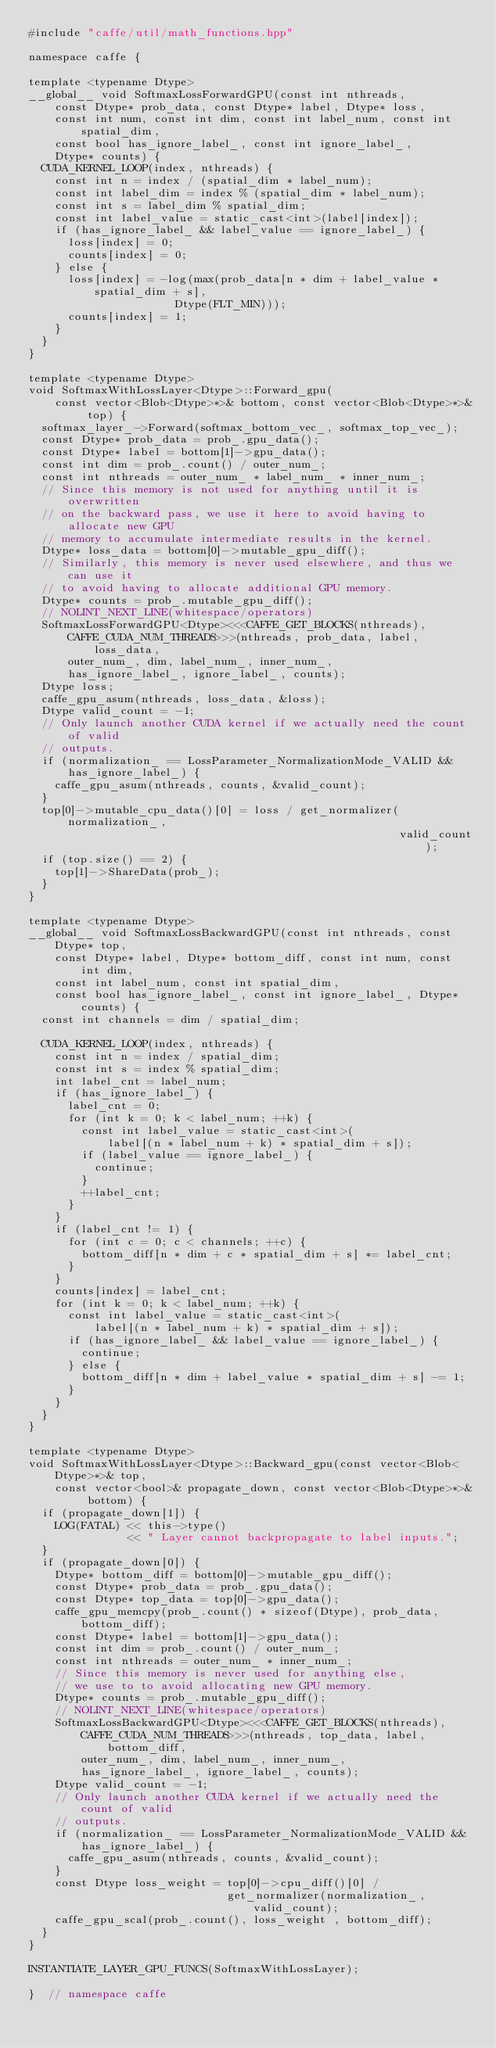<code> <loc_0><loc_0><loc_500><loc_500><_Cuda_>#include "caffe/util/math_functions.hpp"

namespace caffe {

template <typename Dtype>
__global__ void SoftmaxLossForwardGPU(const int nthreads,
    const Dtype* prob_data, const Dtype* label, Dtype* loss,
    const int num, const int dim, const int label_num, const int spatial_dim,
    const bool has_ignore_label_, const int ignore_label_,
    Dtype* counts) {
  CUDA_KERNEL_LOOP(index, nthreads) {
    const int n = index / (spatial_dim * label_num);
    const int label_dim = index % (spatial_dim * label_num);
    const int s = label_dim % spatial_dim;
    const int label_value = static_cast<int>(label[index]);
    if (has_ignore_label_ && label_value == ignore_label_) {
      loss[index] = 0;
      counts[index] = 0;
    } else {
      loss[index] = -log(max(prob_data[n * dim + label_value * spatial_dim + s],
                      Dtype(FLT_MIN)));
      counts[index] = 1;
    }
  }
}

template <typename Dtype>
void SoftmaxWithLossLayer<Dtype>::Forward_gpu(
    const vector<Blob<Dtype>*>& bottom, const vector<Blob<Dtype>*>& top) {
  softmax_layer_->Forward(softmax_bottom_vec_, softmax_top_vec_);
  const Dtype* prob_data = prob_.gpu_data();
  const Dtype* label = bottom[1]->gpu_data();
  const int dim = prob_.count() / outer_num_;
  const int nthreads = outer_num_ * label_num_ * inner_num_;
  // Since this memory is not used for anything until it is overwritten
  // on the backward pass, we use it here to avoid having to allocate new GPU
  // memory to accumulate intermediate results in the kernel.
  Dtype* loss_data = bottom[0]->mutable_gpu_diff();
  // Similarly, this memory is never used elsewhere, and thus we can use it
  // to avoid having to allocate additional GPU memory.
  Dtype* counts = prob_.mutable_gpu_diff();
  // NOLINT_NEXT_LINE(whitespace/operators)
  SoftmaxLossForwardGPU<Dtype><<<CAFFE_GET_BLOCKS(nthreads),
      CAFFE_CUDA_NUM_THREADS>>>(nthreads, prob_data, label, loss_data,
      outer_num_, dim, label_num_, inner_num_,
      has_ignore_label_, ignore_label_, counts);
  Dtype loss;
  caffe_gpu_asum(nthreads, loss_data, &loss);
  Dtype valid_count = -1;
  // Only launch another CUDA kernel if we actually need the count of valid
  // outputs.
  if (normalization_ == LossParameter_NormalizationMode_VALID &&
      has_ignore_label_) {
    caffe_gpu_asum(nthreads, counts, &valid_count);
  }
  top[0]->mutable_cpu_data()[0] = loss / get_normalizer(normalization_,
                                                        valid_count);
  if (top.size() == 2) {
    top[1]->ShareData(prob_);
  }
}

template <typename Dtype>
__global__ void SoftmaxLossBackwardGPU(const int nthreads, const Dtype* top,
    const Dtype* label, Dtype* bottom_diff, const int num, const int dim,
    const int label_num, const int spatial_dim,
    const bool has_ignore_label_, const int ignore_label_, Dtype* counts) {
  const int channels = dim / spatial_dim;

  CUDA_KERNEL_LOOP(index, nthreads) {
    const int n = index / spatial_dim;
    const int s = index % spatial_dim;
    int label_cnt = label_num;
    if (has_ignore_label_) {
      label_cnt = 0;
      for (int k = 0; k < label_num; ++k) {
        const int label_value = static_cast<int>(
            label[(n * label_num + k) * spatial_dim + s]);
        if (label_value == ignore_label_) {
          continue;
        }
        ++label_cnt;
      }
    }
    if (label_cnt != 1) {
      for (int c = 0; c < channels; ++c) {
        bottom_diff[n * dim + c * spatial_dim + s] *= label_cnt;
      }
    }
    counts[index] = label_cnt;
    for (int k = 0; k < label_num; ++k) {
      const int label_value = static_cast<int>(
          label[(n * label_num + k) * spatial_dim + s]);
      if (has_ignore_label_ && label_value == ignore_label_) {
        continue;
      } else {
        bottom_diff[n * dim + label_value * spatial_dim + s] -= 1;
      }
    }
  }
}

template <typename Dtype>
void SoftmaxWithLossLayer<Dtype>::Backward_gpu(const vector<Blob<Dtype>*>& top,
    const vector<bool>& propagate_down, const vector<Blob<Dtype>*>& bottom) {
  if (propagate_down[1]) {
    LOG(FATAL) << this->type()
               << " Layer cannot backpropagate to label inputs.";
  }
  if (propagate_down[0]) {
    Dtype* bottom_diff = bottom[0]->mutable_gpu_diff();
    const Dtype* prob_data = prob_.gpu_data();
    const Dtype* top_data = top[0]->gpu_data();
    caffe_gpu_memcpy(prob_.count() * sizeof(Dtype), prob_data, bottom_diff);
    const Dtype* label = bottom[1]->gpu_data();
    const int dim = prob_.count() / outer_num_;
    const int nthreads = outer_num_ * inner_num_;
    // Since this memory is never used for anything else,
    // we use to to avoid allocating new GPU memory.
    Dtype* counts = prob_.mutable_gpu_diff();
    // NOLINT_NEXT_LINE(whitespace/operators)
    SoftmaxLossBackwardGPU<Dtype><<<CAFFE_GET_BLOCKS(nthreads),
        CAFFE_CUDA_NUM_THREADS>>>(nthreads, top_data, label, bottom_diff,
        outer_num_, dim, label_num_, inner_num_,
        has_ignore_label_, ignore_label_, counts);
    Dtype valid_count = -1;
    // Only launch another CUDA kernel if we actually need the count of valid
    // outputs.
    if (normalization_ == LossParameter_NormalizationMode_VALID &&
        has_ignore_label_) {
      caffe_gpu_asum(nthreads, counts, &valid_count);
    }
    const Dtype loss_weight = top[0]->cpu_diff()[0] /
                              get_normalizer(normalization_, valid_count);
    caffe_gpu_scal(prob_.count(), loss_weight , bottom_diff);
  }
}

INSTANTIATE_LAYER_GPU_FUNCS(SoftmaxWithLossLayer);

}  // namespace caffe
</code> 